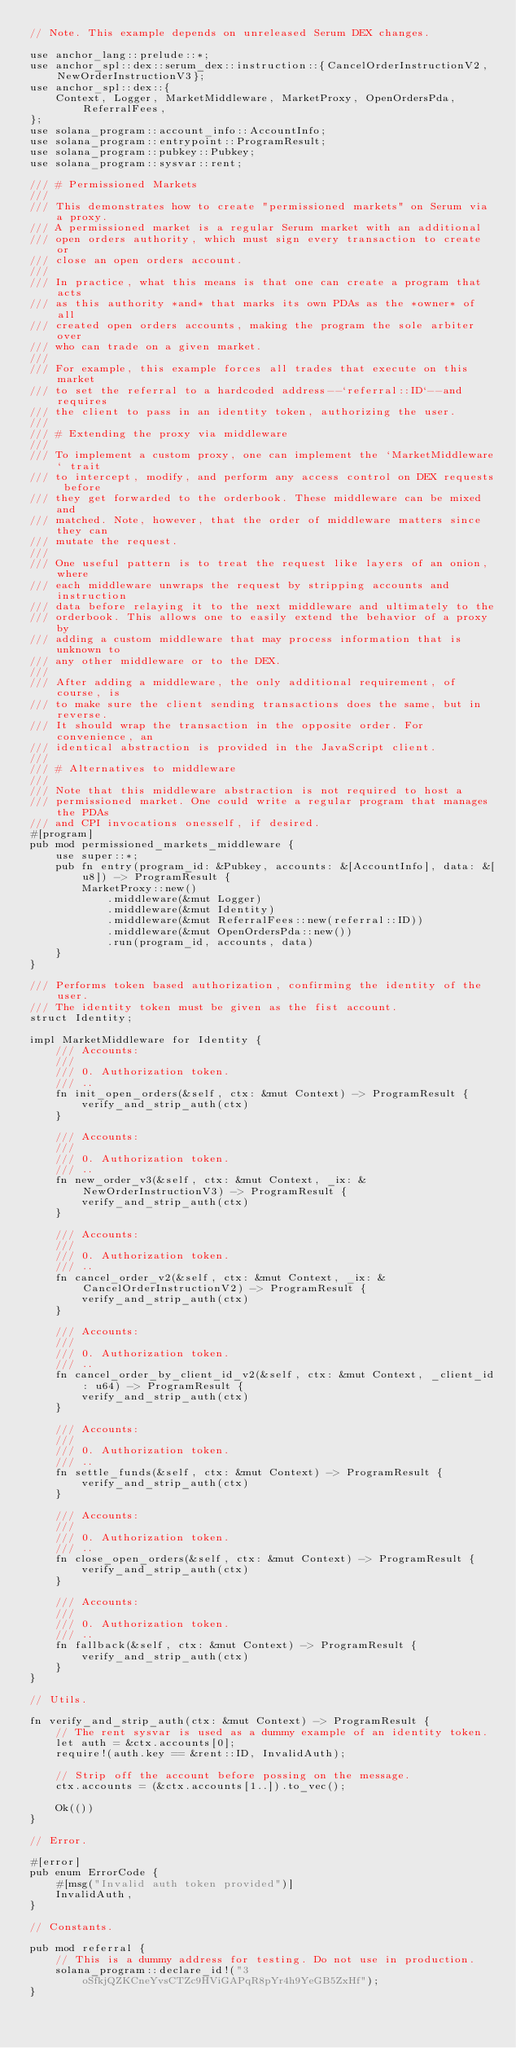Convert code to text. <code><loc_0><loc_0><loc_500><loc_500><_Rust_>// Note. This example depends on unreleased Serum DEX changes.

use anchor_lang::prelude::*;
use anchor_spl::dex::serum_dex::instruction::{CancelOrderInstructionV2, NewOrderInstructionV3};
use anchor_spl::dex::{
    Context, Logger, MarketMiddleware, MarketProxy, OpenOrdersPda, ReferralFees,
};
use solana_program::account_info::AccountInfo;
use solana_program::entrypoint::ProgramResult;
use solana_program::pubkey::Pubkey;
use solana_program::sysvar::rent;

/// # Permissioned Markets
///
/// This demonstrates how to create "permissioned markets" on Serum via a proxy.
/// A permissioned market is a regular Serum market with an additional
/// open orders authority, which must sign every transaction to create or
/// close an open orders account.
///
/// In practice, what this means is that one can create a program that acts
/// as this authority *and* that marks its own PDAs as the *owner* of all
/// created open orders accounts, making the program the sole arbiter over
/// who can trade on a given market.
///
/// For example, this example forces all trades that execute on this market
/// to set the referral to a hardcoded address--`referral::ID`--and requires
/// the client to pass in an identity token, authorizing the user.
///
/// # Extending the proxy via middleware
///
/// To implement a custom proxy, one can implement the `MarketMiddleware` trait
/// to intercept, modify, and perform any access control on DEX requests before
/// they get forwarded to the orderbook. These middleware can be mixed and
/// matched. Note, however, that the order of middleware matters since they can
/// mutate the request.
///
/// One useful pattern is to treat the request like layers of an onion, where
/// each middleware unwraps the request by stripping accounts and instruction
/// data before relaying it to the next middleware and ultimately to the
/// orderbook. This allows one to easily extend the behavior of a proxy by
/// adding a custom middleware that may process information that is unknown to
/// any other middleware or to the DEX.
///
/// After adding a middleware, the only additional requirement, of course, is
/// to make sure the client sending transactions does the same, but in reverse.
/// It should wrap the transaction in the opposite order. For convenience, an
/// identical abstraction is provided in the JavaScript client.
///
/// # Alternatives to middleware
///
/// Note that this middleware abstraction is not required to host a
/// permissioned market. One could write a regular program that manages the PDAs
/// and CPI invocations onesself, if desired.
#[program]
pub mod permissioned_markets_middleware {
    use super::*;
    pub fn entry(program_id: &Pubkey, accounts: &[AccountInfo], data: &[u8]) -> ProgramResult {
        MarketProxy::new()
            .middleware(&mut Logger)
            .middleware(&mut Identity)
            .middleware(&mut ReferralFees::new(referral::ID))
            .middleware(&mut OpenOrdersPda::new())
            .run(program_id, accounts, data)
    }
}

/// Performs token based authorization, confirming the identity of the user.
/// The identity token must be given as the fist account.
struct Identity;

impl MarketMiddleware for Identity {
    /// Accounts:
    ///
    /// 0. Authorization token.
    /// ..
    fn init_open_orders(&self, ctx: &mut Context) -> ProgramResult {
        verify_and_strip_auth(ctx)
    }

    /// Accounts:
    ///
    /// 0. Authorization token.
    /// ..
    fn new_order_v3(&self, ctx: &mut Context, _ix: &NewOrderInstructionV3) -> ProgramResult {
        verify_and_strip_auth(ctx)
    }

    /// Accounts:
    ///
    /// 0. Authorization token.
    /// ..
    fn cancel_order_v2(&self, ctx: &mut Context, _ix: &CancelOrderInstructionV2) -> ProgramResult {
        verify_and_strip_auth(ctx)
    }

    /// Accounts:
    ///
    /// 0. Authorization token.
    /// ..
    fn cancel_order_by_client_id_v2(&self, ctx: &mut Context, _client_id: u64) -> ProgramResult {
        verify_and_strip_auth(ctx)
    }

    /// Accounts:
    ///
    /// 0. Authorization token.
    /// ..
    fn settle_funds(&self, ctx: &mut Context) -> ProgramResult {
        verify_and_strip_auth(ctx)
    }

    /// Accounts:
    ///
    /// 0. Authorization token.
    /// ..
    fn close_open_orders(&self, ctx: &mut Context) -> ProgramResult {
        verify_and_strip_auth(ctx)
    }

    /// Accounts:
    ///
    /// 0. Authorization token.
    /// ..
    fn fallback(&self, ctx: &mut Context) -> ProgramResult {
        verify_and_strip_auth(ctx)
    }
}

// Utils.

fn verify_and_strip_auth(ctx: &mut Context) -> ProgramResult {
    // The rent sysvar is used as a dummy example of an identity token.
    let auth = &ctx.accounts[0];
    require!(auth.key == &rent::ID, InvalidAuth);

    // Strip off the account before possing on the message.
    ctx.accounts = (&ctx.accounts[1..]).to_vec();

    Ok(())
}

// Error.

#[error]
pub enum ErrorCode {
    #[msg("Invalid auth token provided")]
    InvalidAuth,
}

// Constants.

pub mod referral {
    // This is a dummy address for testing. Do not use in production.
    solana_program::declare_id!("3oSfkjQZKCneYvsCTZc9HViGAPqR8pYr4h9YeGB5ZxHf");
}
</code> 